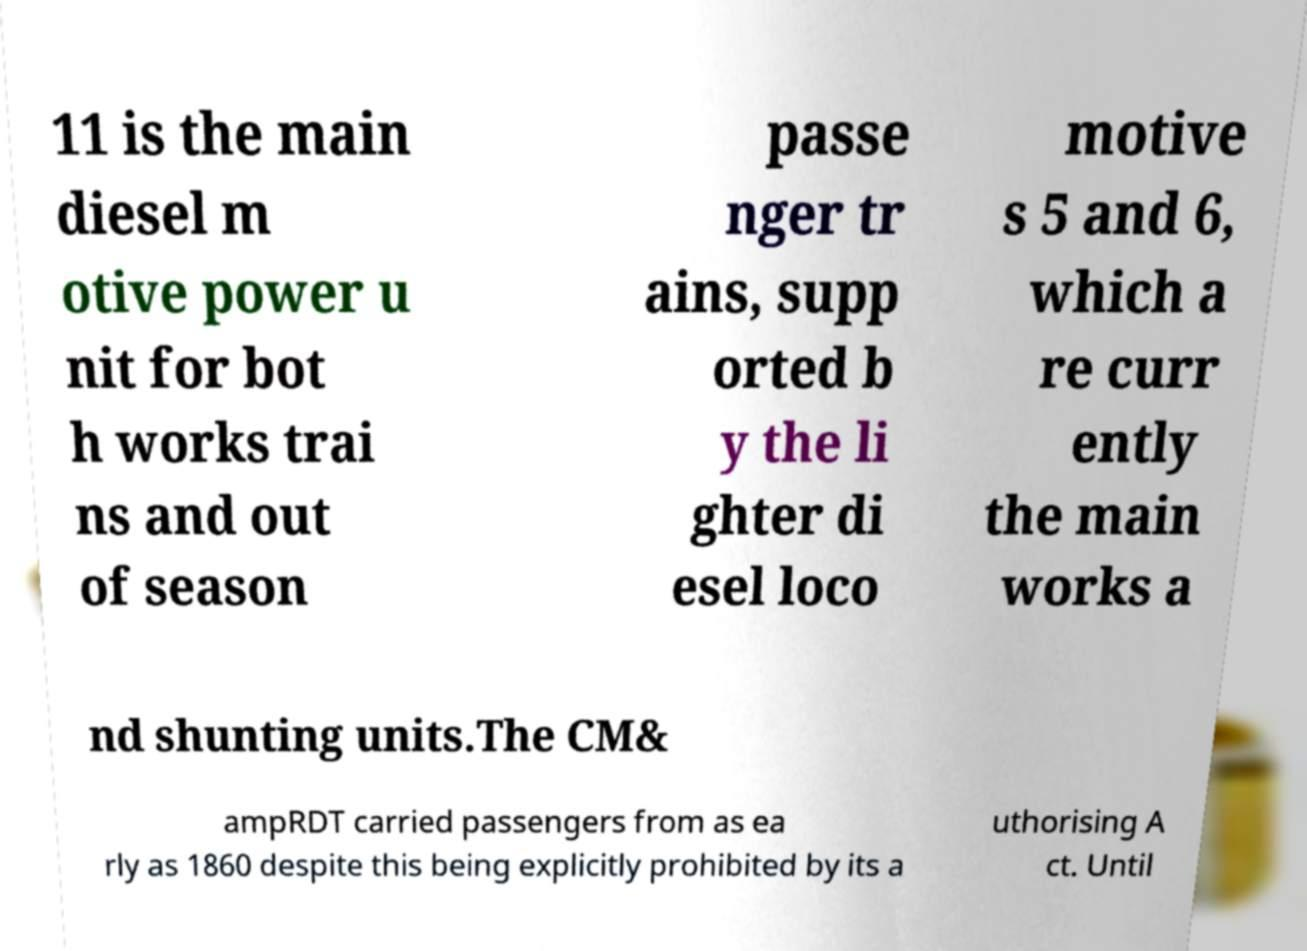Could you extract and type out the text from this image? 11 is the main diesel m otive power u nit for bot h works trai ns and out of season passe nger tr ains, supp orted b y the li ghter di esel loco motive s 5 and 6, which a re curr ently the main works a nd shunting units.The CM& ampRDT carried passengers from as ea rly as 1860 despite this being explicitly prohibited by its a uthorising A ct. Until 